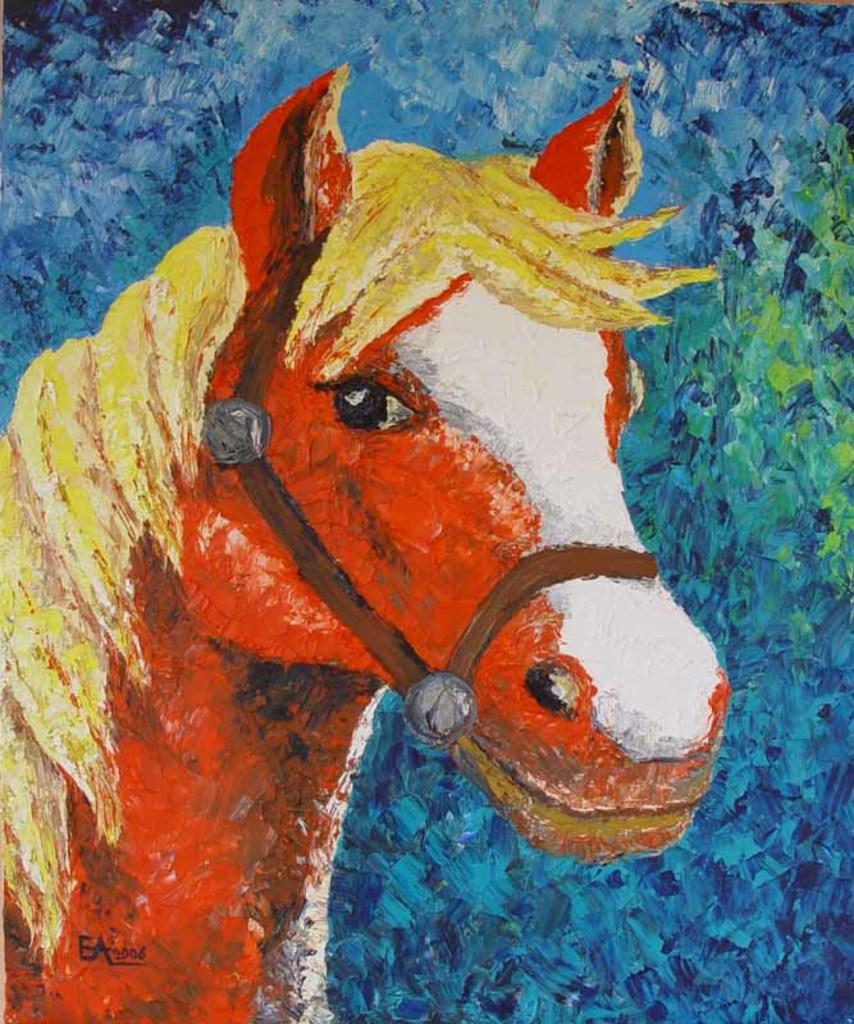What is the main subject of the painting in the image? The painting depicts a horse. How are the colors used in the painting? The horse is portrayed with different colors. What type of blood is visible on the horse's coat in the painting? There is no blood visible on the horse's coat in the painting. What type of cabbage is being used as a prop in the painting? There are no cabbages present in the painting; it features a horse depicted with different colors. 